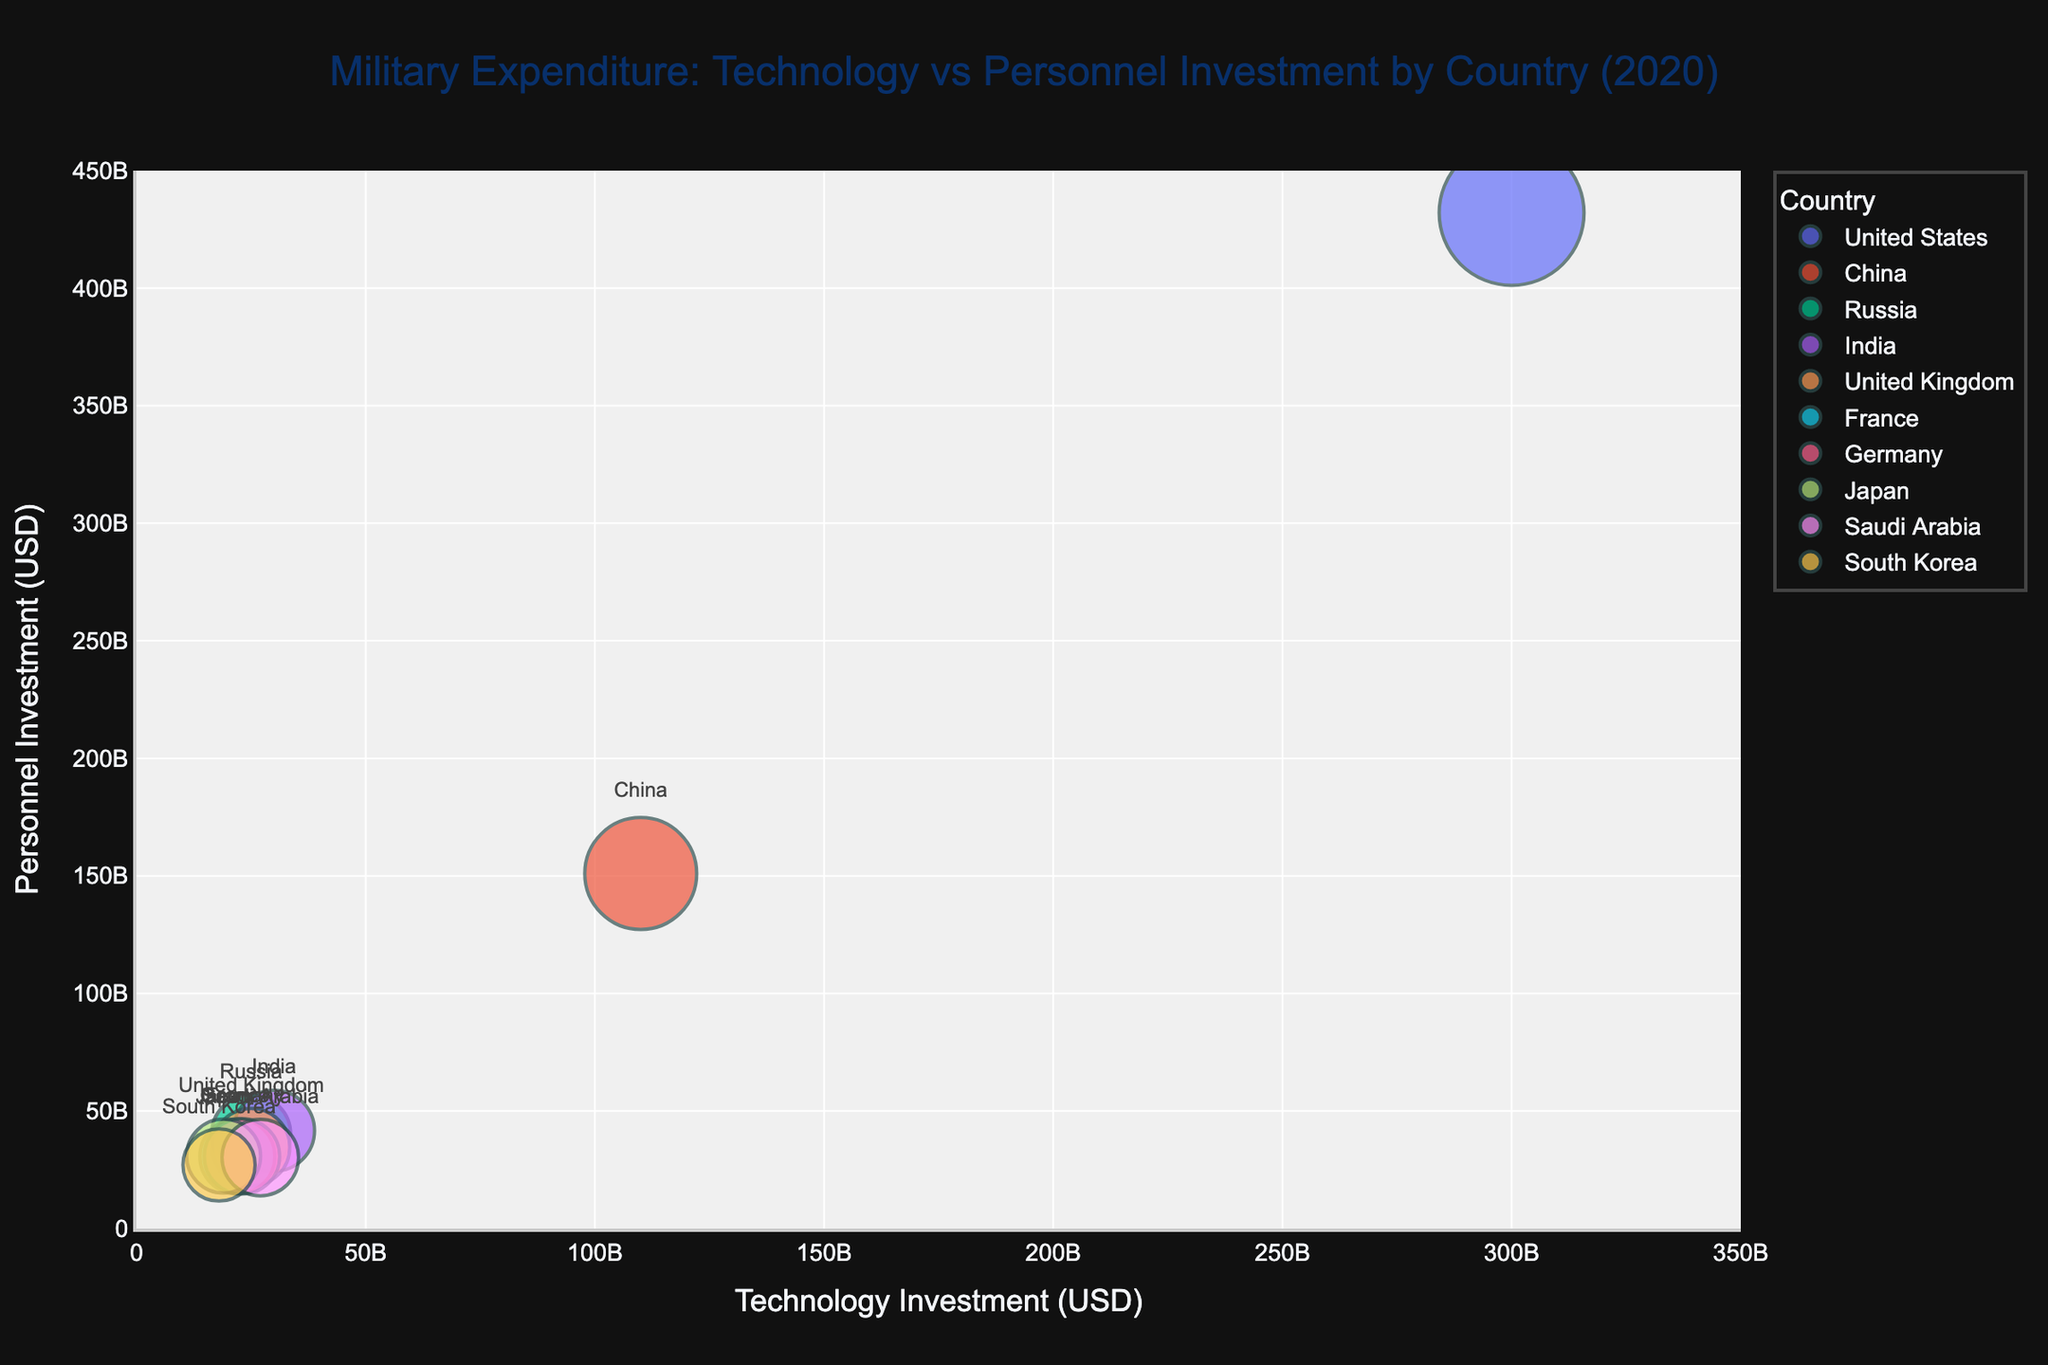What's the title of the chart? The title is usually located at the top center of the chart. In this case, it reads "Military Expenditure: Technology vs Personnel Investment by Country (2020)".
Answer: Military Expenditure: Technology vs Personnel Investment by Country (2020) Which country has the highest technology investment? The bubble representing the highest technology investment will be positioned furthest to the right on the x-axis. The United States is furthest to the right, indicating the highest technology investment.
Answer: United States Which country has the lowest personnel investment? The country with the lowest personnel investment will be positioned lowest on the y-axis. Russia is positioned lowest, indicating the lowest personnel investment.
Answer: Russia Which color represents China on the chart? The legend at the right helps identify the colors for each country. The color for China should match the color shown next to the label "China" in the legend.
Answer: Same as legend (color data not given) How does the personnel investment of India compare with that of France? Locate the bubbles for India and France on the y-axis to compare their personnel investments. India's bubble is higher than France's, indicating higher personnel investment.
Answer: Higher What is the bubble size used to represent the expenditure of the United Kingdom? Bubble sizes are derived from the "Bubble_Size" column, which scales with total expenditure. The United Kingdom's bubble appears considerably larger than others except the United States and China.
Answer: Large Among the countries listed, who spends more on technology investment, Germany or Japan? Locate the bubbles for Germany and Japan on the x-axis to compare their technology investments. Germany's bubble is slightly to the right of Japan's, indicating higher technology investment.
Answer: Germany On the chart, which country is closest to the origin (0,0)? The closest bubble to the bottom left corner (origin) on both axes represents the country. Russia is closest to the origin, indicating the lowest combined technology and personnel investment.
Answer: Russia If you sum the total expenditure investments for France and Germany, what would be the size of the resulting bubble? Add the total expenditures: 527 billion USD (France) + 537 billion USD (Germany) = 1064 billion USD. Calculate the square root for the bubble size: √(1064) ≈ 32.62 (scaled for better visibility).
Answer: About 32.62 